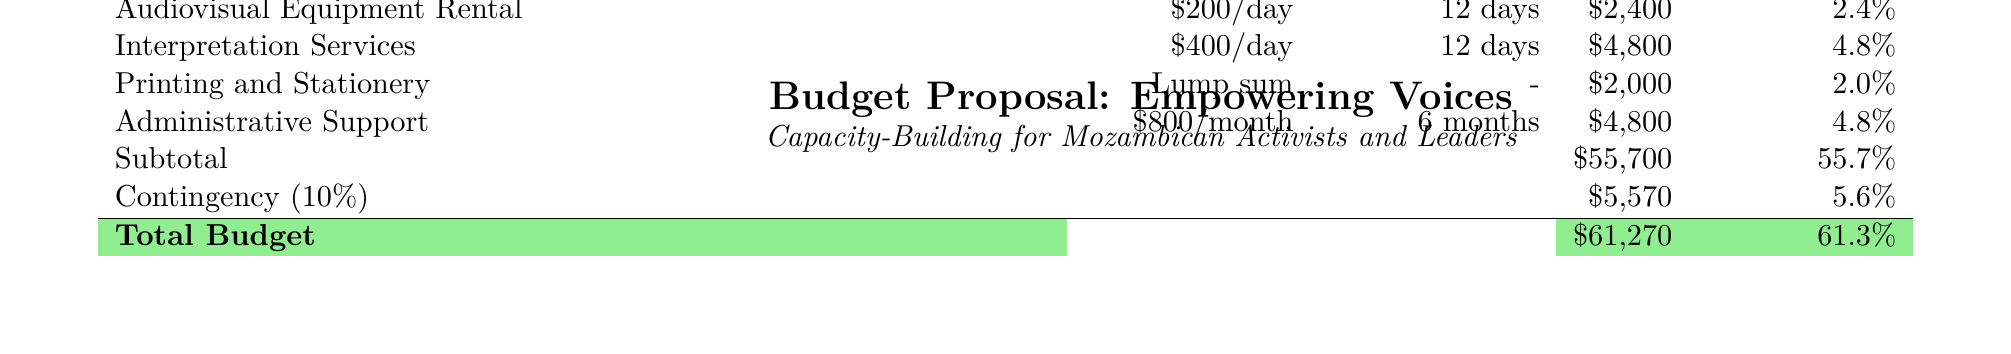What is the duration of the workshops? The duration of the workshops is specified in the document as 6 months.
Answer: 6 months How many workshops are planned? The document states that there will be 12 workshops conducted over the duration.
Answer: 12 What is the total funding amount? The total funding amount is a summation of all funding sources listed in the document.
Answer: $100,000 What is the participant travel allowance per person? The document provides the participant travel allowance rate as listed.
Answer: $50/person What percentage of the budget is allocated for venue rental? The venue rental cost as a percentage of the total budget can be found under the budget breakdown.
Answer: 6.0% How much is allocated for participant travel allowances in total? The total for participant travel allowances is calculated based on the number of participants and the allowance per person.
Answer: $15,000 What is the unit cost of facilitator fees? The unit cost of facilitator fees is explicitly mentioned in the budget breakdown.
Answer: $300/day What is the total amount for training materials? The total for training materials can be found in the budget breakdown from the calculations provided.
Answer: $9,000 What is the contingency percentage in the budget? The contingency percentage is explicitly stated as a part of the budget summary.
Answer: 10% What is the venue for the workshops? The document specifies the venue for the workshops clearly in the workshop details section.
Answer: Centro de Conferências Joaquim Chissano, Maputo 